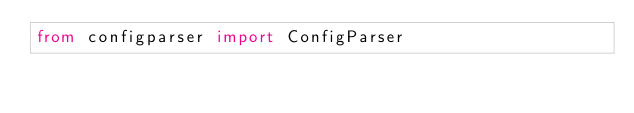<code> <loc_0><loc_0><loc_500><loc_500><_Python_>from configparser import ConfigParser</code> 